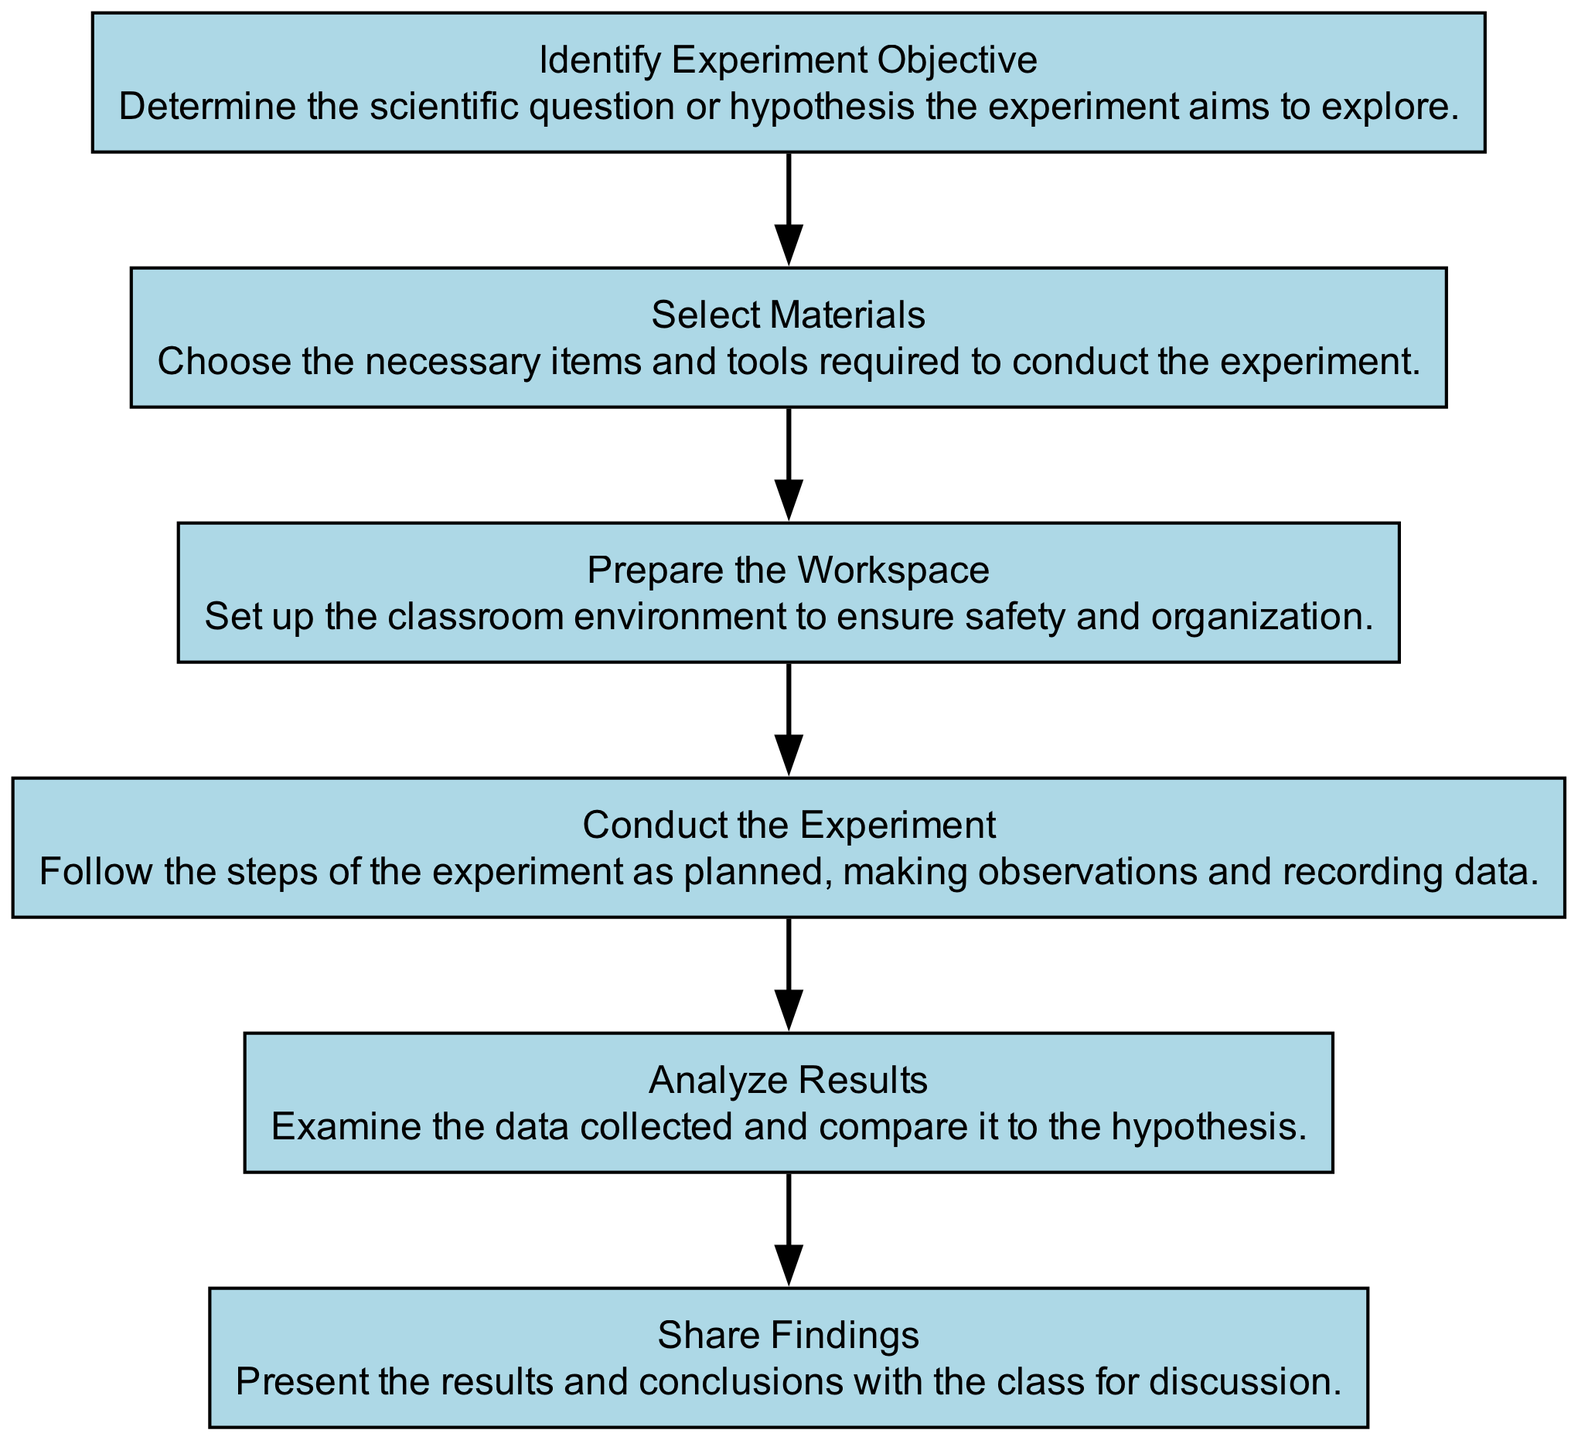What is the first step in the process? The diagram's first node is labeled "Identify Experiment Objective," indicating that this is the initial action taken in the setup process.
Answer: Identify Experiment Objective How many steps are there in total? The diagram contains six nodes, each representing a different step in the classroom experiment setup process.
Answer: Six What is the final action outlined in the diagram? "Share Findings" is the last node in the flowchart, which signifies that this is the concluding step after completing the experiment.
Answer: Share Findings Which step comes after "Conduct the Experiment"? The step that follows "Conduct the Experiment" in the sequence is "Analyze Results," as indicated by the connecting edge from the fourth node to the fifth node.
Answer: Analyze Results What is the relationship between "Select Materials" and "Prepare the Workspace"? In the flowchart, "Select Materials" leads directly to "Prepare the Workspace," indicating that selecting materials must be done prior to preparing the workspace.
Answer: Sequential How does "Analyze Results" relate to "Conduct the Experiment"? "Analyze Results" comes after "Conduct the Experiment" as the next logical step, indicating that the results are analyzed only after the experiment has been conducted.
Answer: Follows Which step involves presenting conclusions? The step labeled "Share Findings" specifically indicates the action of presenting the results and conclusions to the class for further discussion.
Answer: Share Findings How many edges connect the steps in the diagram? There are five edges connecting the six steps, each representing the flow from one step to the next in the setup process.
Answer: Five 